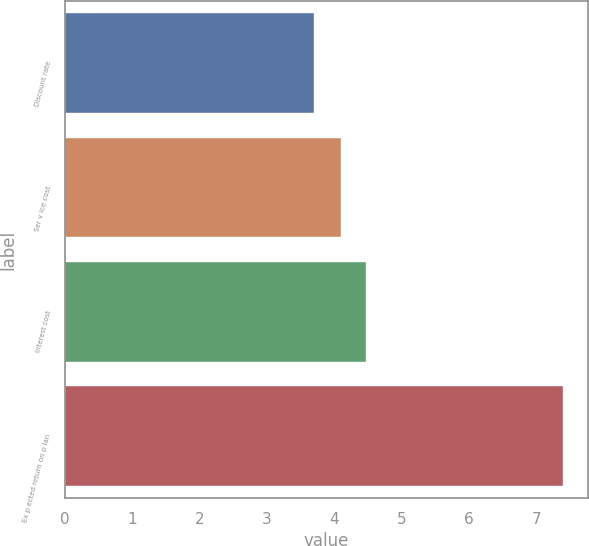Convert chart to OTSL. <chart><loc_0><loc_0><loc_500><loc_500><bar_chart><fcel>Discount rate<fcel>Ser v ice cost<fcel>Interest cost<fcel>Ex p ected return on p lan<nl><fcel>3.7<fcel>4.1<fcel>4.47<fcel>7.4<nl></chart> 